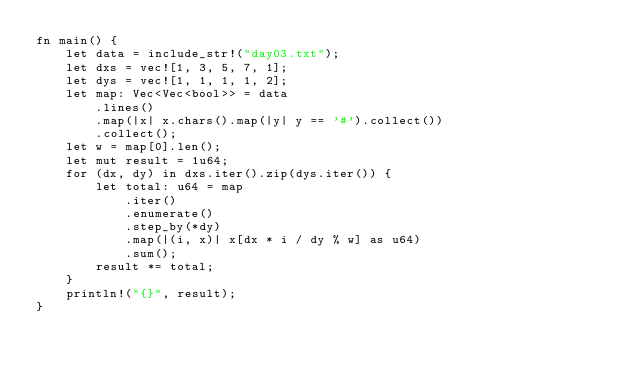<code> <loc_0><loc_0><loc_500><loc_500><_Rust_>fn main() {
    let data = include_str!("day03.txt");
    let dxs = vec![1, 3, 5, 7, 1];
    let dys = vec![1, 1, 1, 1, 2];
    let map: Vec<Vec<bool>> = data
        .lines()
        .map(|x| x.chars().map(|y| y == '#').collect())
        .collect();
    let w = map[0].len();
    let mut result = 1u64;
    for (dx, dy) in dxs.iter().zip(dys.iter()) {
        let total: u64 = map
            .iter()
            .enumerate()
            .step_by(*dy)
            .map(|(i, x)| x[dx * i / dy % w] as u64)
            .sum();
        result *= total;
    }
    println!("{}", result);
}
</code> 